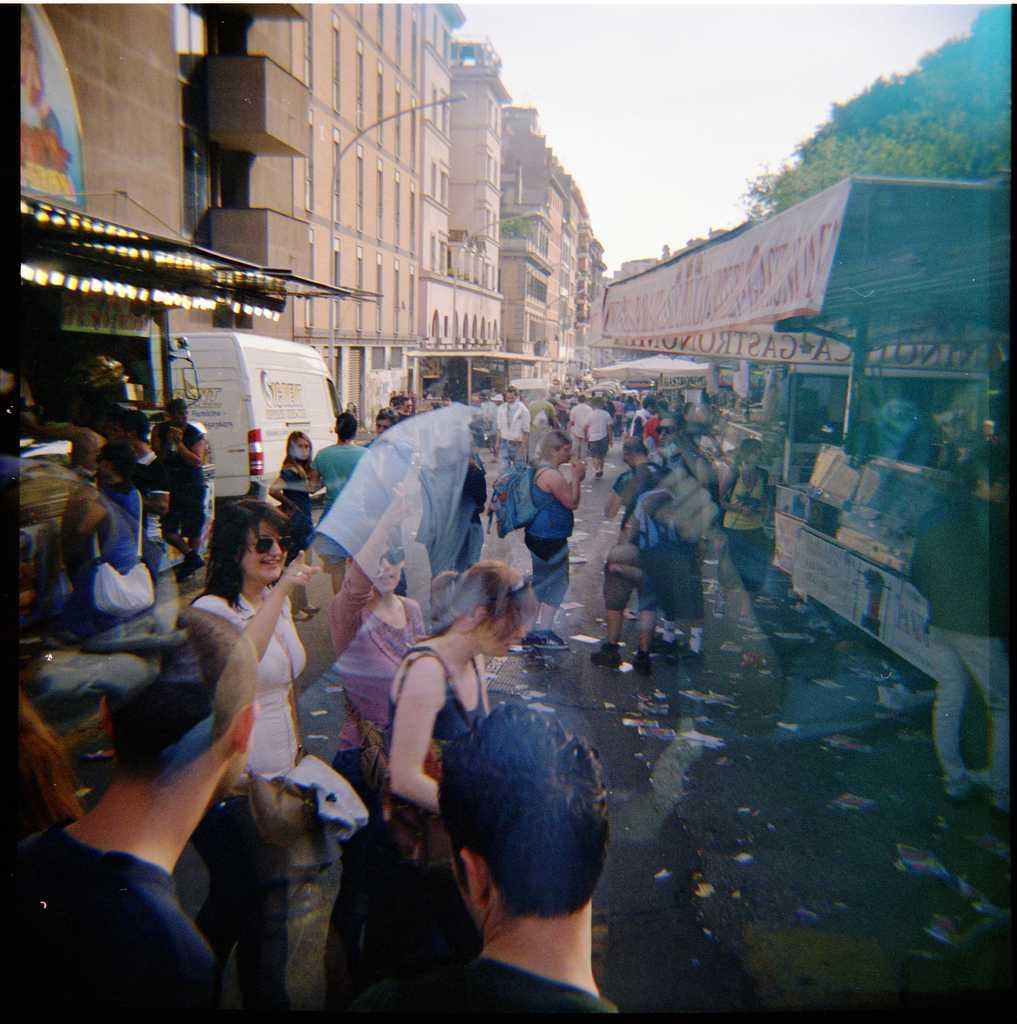Can you describe this image briefly? In this picture I can observe some people standing on the road. There are men and women in this picture. On the left side I can observe white color vehicle. In the background I can observe buildings and sky. 